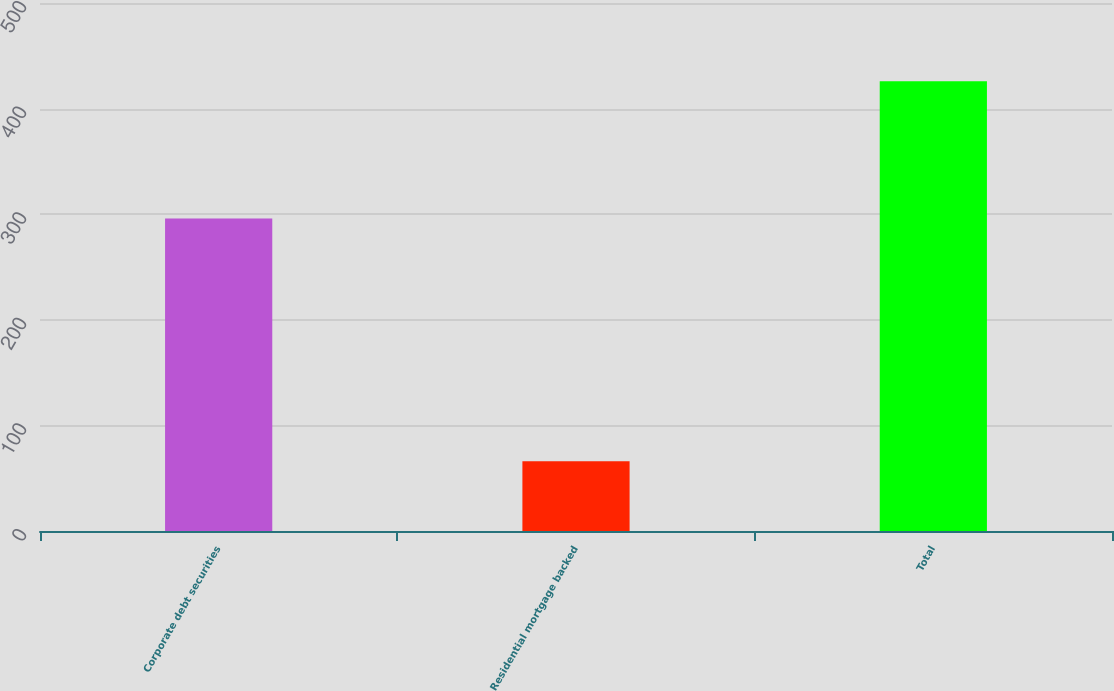Convert chart to OTSL. <chart><loc_0><loc_0><loc_500><loc_500><bar_chart><fcel>Corporate debt securities<fcel>Residential mortgage backed<fcel>Total<nl><fcel>296<fcel>66<fcel>426<nl></chart> 